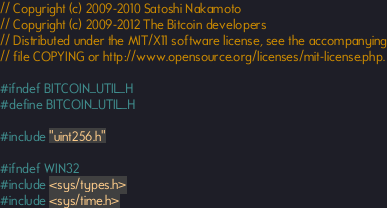<code> <loc_0><loc_0><loc_500><loc_500><_C_>// Copyright (c) 2009-2010 Satoshi Nakamoto
// Copyright (c) 2009-2012 The Bitcoin developers
// Distributed under the MIT/X11 software license, see the accompanying
// file COPYING or http://www.opensource.org/licenses/mit-license.php.

#ifndef BITCOIN_UTIL_H
#define BITCOIN_UTIL_H

#include "uint256.h"

#ifndef WIN32
#include <sys/types.h>
#include <sys/time.h></code> 